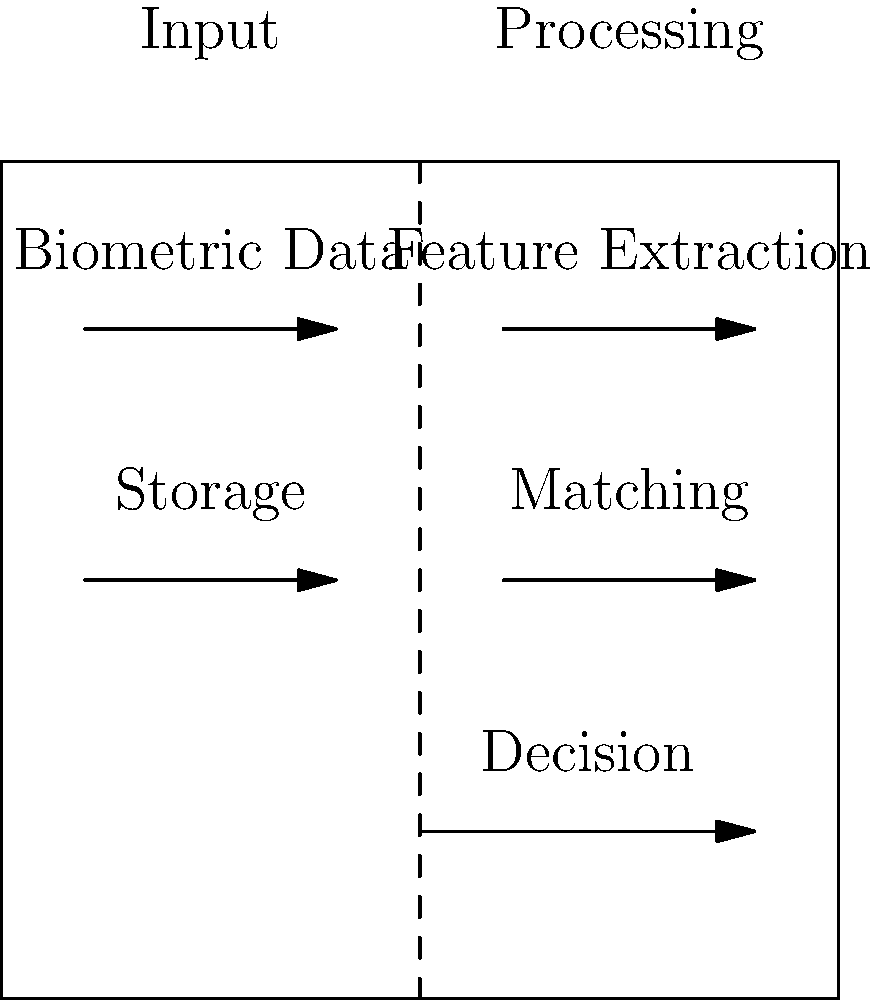In the diagram representing a biometric authentication system, which component is crucial for maintaining user privacy while ensuring system security, and why is it particularly important for a CTO concerned with balancing these two aspects? To answer this question, let's analyze the components of the biometric authentication system shown in the diagram:

1. Input: Biometric data is collected from the user.
2. Feature Extraction: The system processes the raw biometric data to extract unique features.
3. Storage: Previously collected biometric data or templates are stored for comparison.
4. Matching: The extracted features are compared with stored data.
5. Decision: The system determines whether to grant or deny access based on the matching results.

From a privacy and security perspective, the most crucial component is the Storage. Here's why:

1. Privacy Concerns:
   - Biometric data is highly sensitive and personal.
   - If compromised, it cannot be easily changed like passwords.

2. Security Implications:
   - Stored biometric data is a high-value target for attackers.
   - Breaches could lead to identity theft or unauthorized access across multiple systems.

3. Balancing Act for CTOs:
   - Robust storage protects both privacy (by safeguarding personal data) and security (by preventing unauthorized access).
   - Encryption, access controls, and data minimization techniques can be applied to the storage component.

4. Regulatory Compliance:
   - Many data protection regulations (e.g., GDPR, CCPA) have strict requirements for biometric data storage.
   - Proper storage practices help in maintaining compliance.

5. Trust and Reputation:
   - Secure storage of biometric data builds user trust and protects the organization's reputation.

By focusing on the secure storage of biometric data, a CTO can effectively balance the need for strong authentication (security) with the protection of user data (privacy).
Answer: Storage 